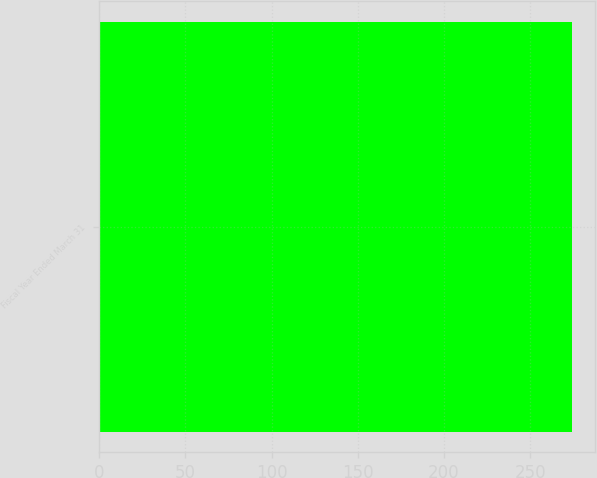Convert chart to OTSL. <chart><loc_0><loc_0><loc_500><loc_500><bar_chart><fcel>Fiscal Year Ended March 31<nl><fcel>274<nl></chart> 